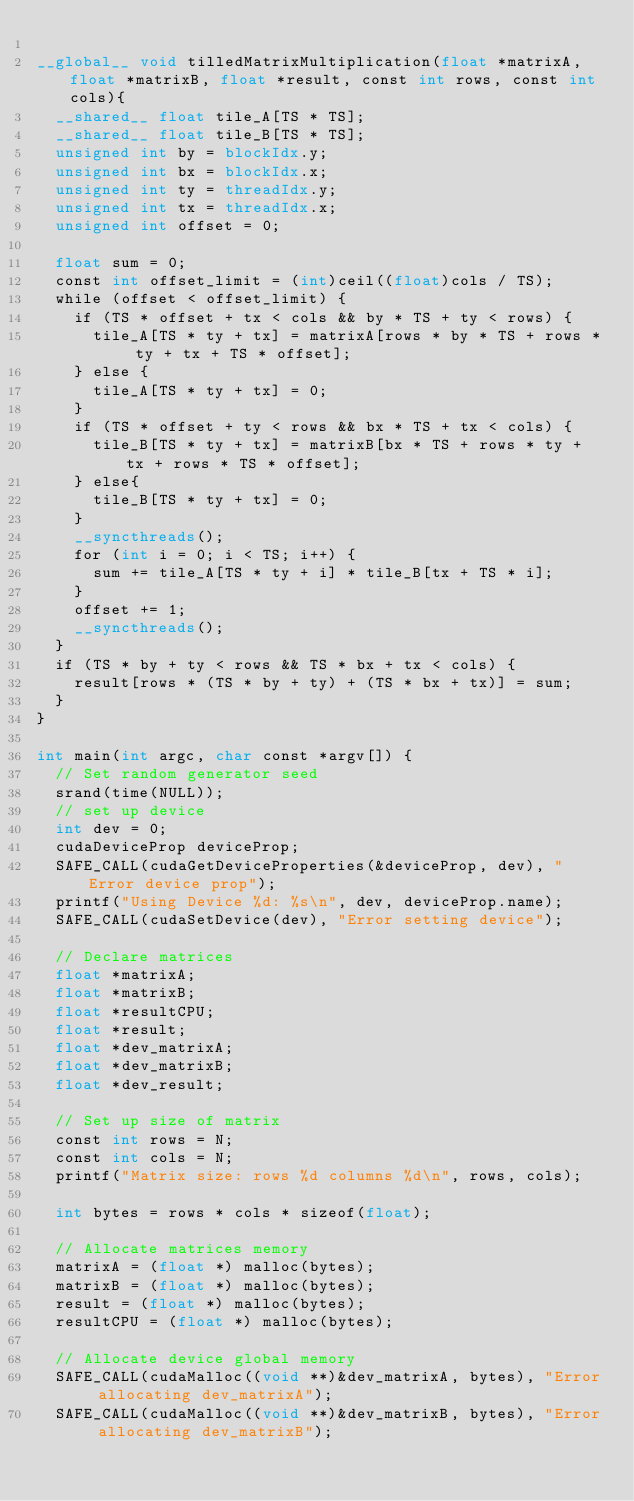<code> <loc_0><loc_0><loc_500><loc_500><_Cuda_>
__global__ void tilledMatrixMultiplication(float *matrixA, float *matrixB, float *result, const int rows, const int cols){
  __shared__ float tile_A[TS * TS];
  __shared__ float tile_B[TS * TS];
  unsigned int by = blockIdx.y;
  unsigned int bx = blockIdx.x;
  unsigned int ty = threadIdx.y;
  unsigned int tx = threadIdx.x;
  unsigned int offset = 0;

  float sum = 0;
  const int offset_limit = (int)ceil((float)cols / TS);
  while (offset < offset_limit) {
    if (TS * offset + tx < cols && by * TS + ty < rows) {
      tile_A[TS * ty + tx] = matrixA[rows * by * TS + rows * ty + tx + TS * offset];
    } else {
      tile_A[TS * ty + tx] = 0;
    }
    if (TS * offset + ty < rows && bx * TS + tx < cols) {
      tile_B[TS * ty + tx] = matrixB[bx * TS + rows * ty + tx + rows * TS * offset];
    } else{
      tile_B[TS * ty + tx] = 0;
    }
    __syncthreads();
    for (int i = 0; i < TS; i++) {
      sum += tile_A[TS * ty + i] * tile_B[tx + TS * i];
    }
    offset += 1;
    __syncthreads();
  }
  if (TS * by + ty < rows && TS * bx + tx < cols) {
    result[rows * (TS * by + ty) + (TS * bx + tx)] = sum;
  }
}

int main(int argc, char const *argv[]) {
  // Set random generator seed
  srand(time(NULL));
  // set up device
  int dev = 0;
  cudaDeviceProp deviceProp;
  SAFE_CALL(cudaGetDeviceProperties(&deviceProp, dev), "Error device prop");
  printf("Using Device %d: %s\n", dev, deviceProp.name);
  SAFE_CALL(cudaSetDevice(dev), "Error setting device");

  // Declare matrices
  float *matrixA;
  float *matrixB;
  float *resultCPU;
  float *result;
  float *dev_matrixA;
  float *dev_matrixB;
  float *dev_result;

  // Set up size of matrix
  const int rows = N;
  const int cols = N;
  printf("Matrix size: rows %d columns %d\n", rows, cols);

  int bytes = rows * cols * sizeof(float);

  // Allocate matrices memory
  matrixA = (float *) malloc(bytes);
  matrixB = (float *) malloc(bytes);
  result = (float *) malloc(bytes);
  resultCPU = (float *) malloc(bytes);

  // Allocate device global memory
  SAFE_CALL(cudaMalloc((void **)&dev_matrixA, bytes), "Error allocating dev_matrixA");
  SAFE_CALL(cudaMalloc((void **)&dev_matrixB, bytes), "Error allocating dev_matrixB");</code> 